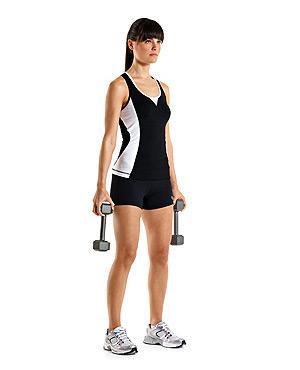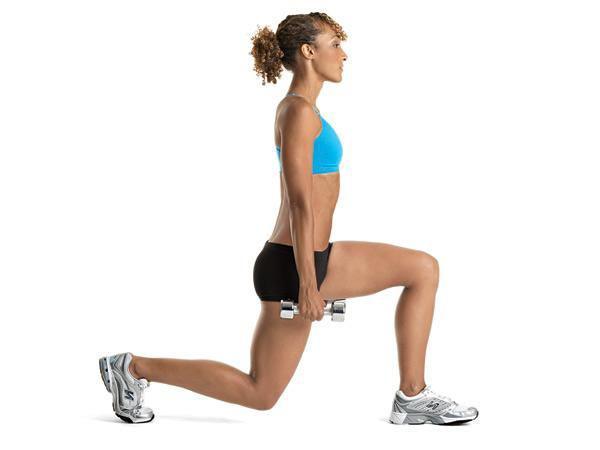The first image is the image on the left, the second image is the image on the right. Evaluate the accuracy of this statement regarding the images: "An image shows a girl in sports bra and short black shorts doing a lunge without a mat while holding dumbbells.". Is it true? Answer yes or no. Yes. The first image is the image on the left, the second image is the image on the right. Considering the images on both sides, is "A woman is in lunge position with weights down." valid? Answer yes or no. Yes. 